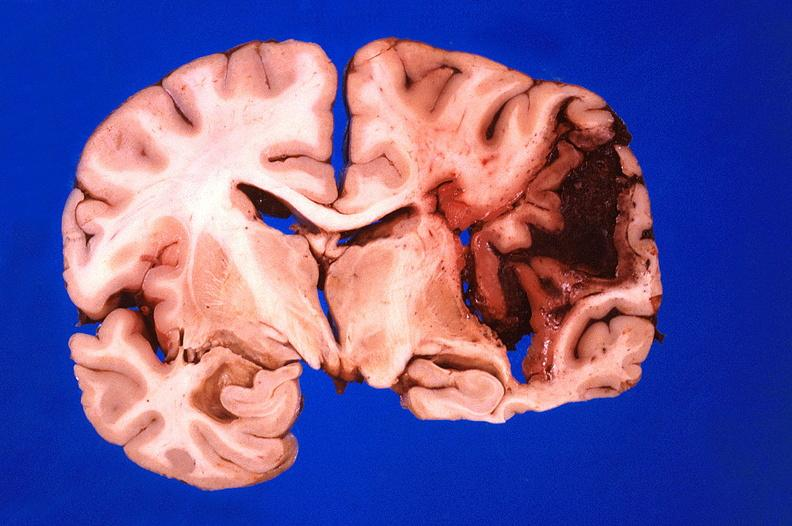what does this image show?
Answer the question using a single word or phrase. Brain 